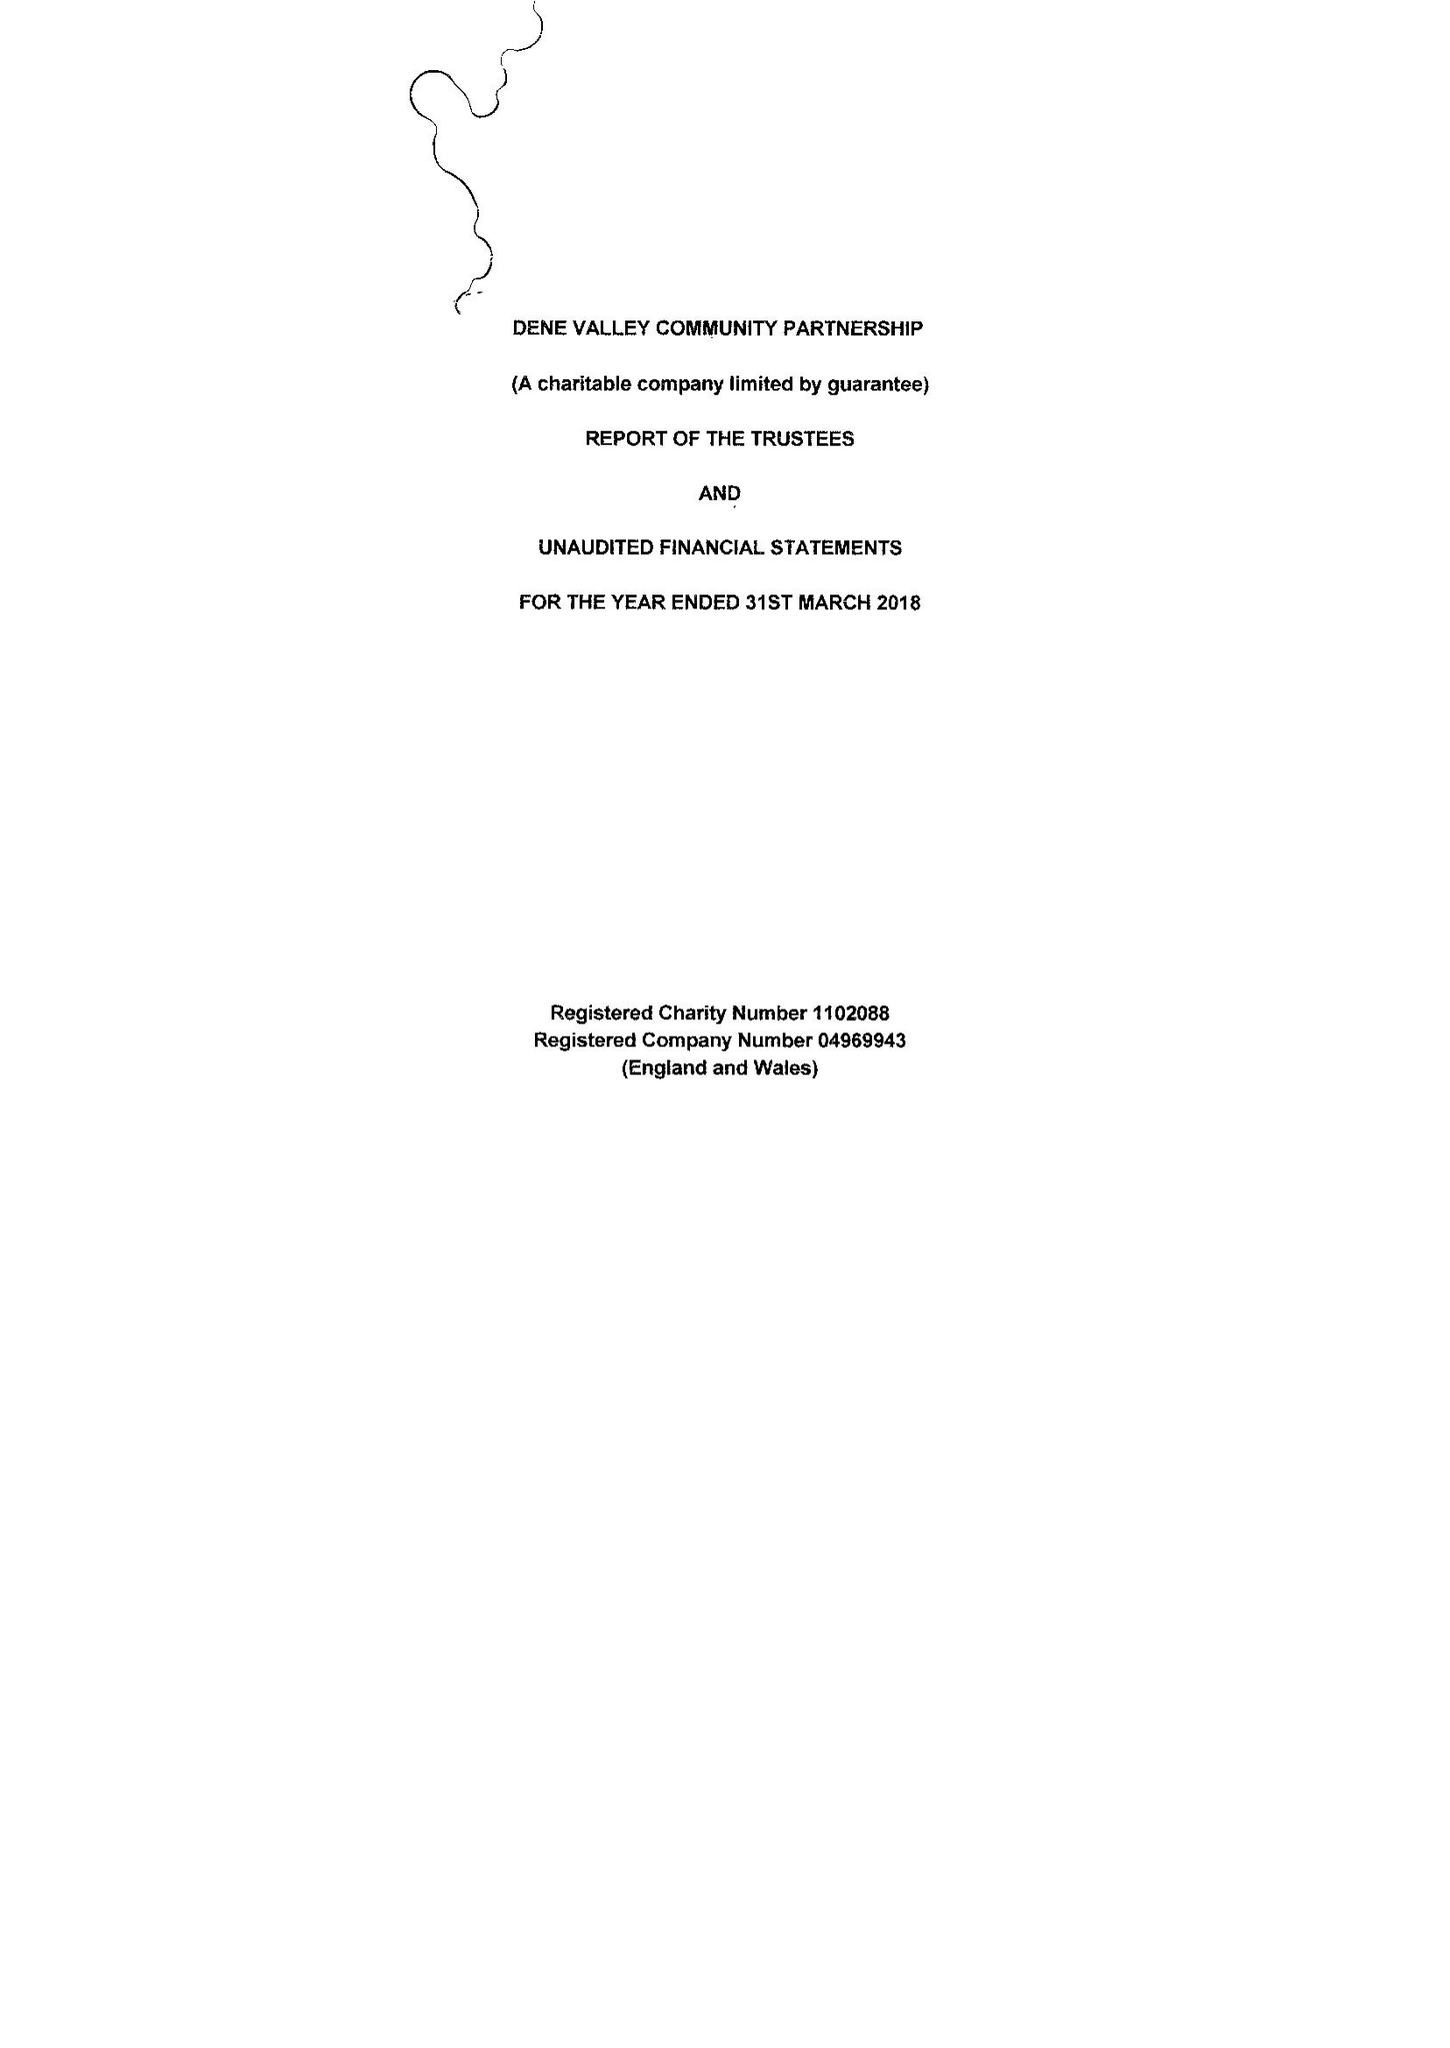What is the value for the address__post_town?
Answer the question using a single word or phrase. BISHOP AUCKLAND 